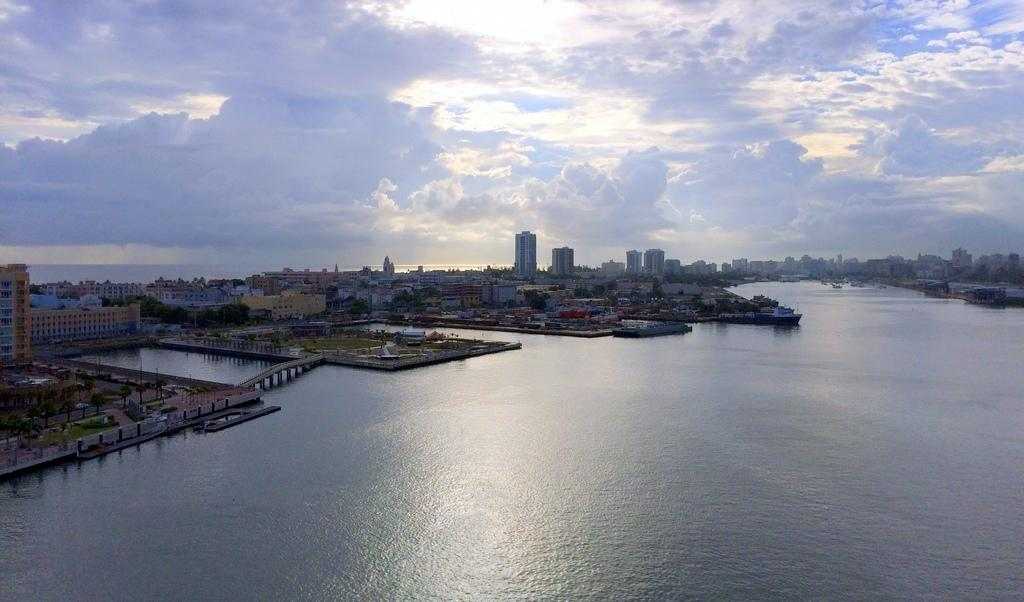What is the primary element visible in the image? There is water in the image. What type of structures can be seen in the image? There are many buildings in the image. What type of vegetation is present in the image? There are trees in the image. What type of man-made structures can be seen in the image? There are poles in the image. What type of infrastructure is present in the image? There is a bridge in the image. What is visible at the top of the image? The sky is visible at the top of the image. What can be seen in the sky? Clouds are present in the sky. What type of plate is being used to hold the clouds in the image? There is no plate present in the image; the clouds are in the sky. Is there a sidewalk visible in the image? There is no sidewalk visible in the image. 